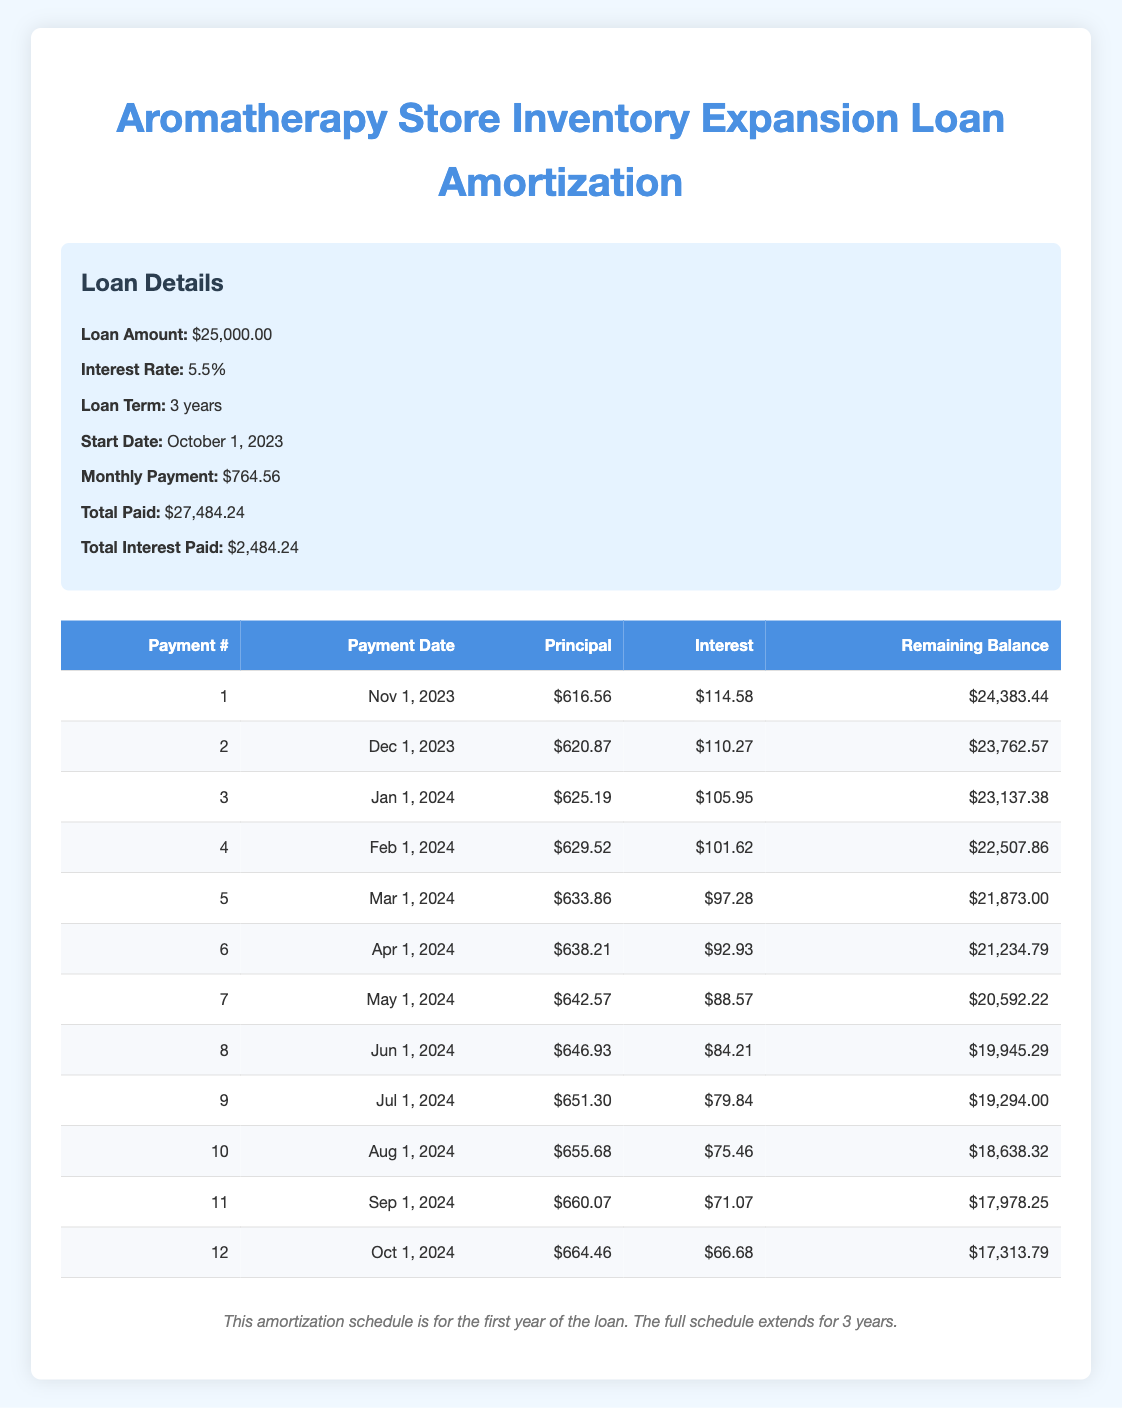What is the total amount paid over the life of the loan? The total paid over the life of the loan is stated in the loan details section of the table as $27,484.24.
Answer: $27,484.24 How much is the monthly payment? The monthly payment amount is listed in the loan details section as $764.56.
Answer: $764.56 What is the remaining balance after the first payment? The remaining balance after the first payment is detailed in the payment schedule, where it states $24,383.44 after the first payment.
Answer: $24,383.44 How much interest is paid in the second month? The interest payment for the second month, as shown in the payment schedule, is $110.27.
Answer: $110.27 What is the total principal paid after the first six payments? The principal payments for the first six payments, which are $616.56, $620.87, $625.19, $629.52, $633.86, and $638.21 can be summed up: 616.56 + 620.87 + 625.19 + 629.52 + 633.86 + 638.21 = $3,364.21.
Answer: $3,364.21 Is the interest payment for the tenth month less than the interest payment for the first month? The interest for the tenth month is $75.46 and the interest for the first month is $114.58. Comparing these values, $75.46 is indeed less than $114.58.
Answer: Yes What is the total amount of interest paid after the first year? To find the total interest paid after the first year, we would sum the monthly interest payments for the first 12 payments: $114.58 + $110.27 + $105.95 + $101.62 + $97.28 + $92.93 + $88.57 + $84.21 + $79.84 + $75.46 + $71.07 + $66.68 = $1,216.80.
Answer: $1,216.80 Which payment shows the highest principal payment and what is that amount? By reviewing the principal payments in the payment schedule, the highest payment is $664.46 for the twelfth payment.
Answer: $664.46 How much has the remaining balance decreased after the first year? Initially, the loan amount is $25,000. After 12 payments, the remaining balance is $17,313.79. The decrease in balance is $25,000 - $17,313.79 = $7,686.21.
Answer: $7,686.21 What was the interest paid in the last month of the first year? The interest paid in the last month (12th payment) of the first year is clearly stated as $66.68 in the payment schedule.
Answer: $66.68 